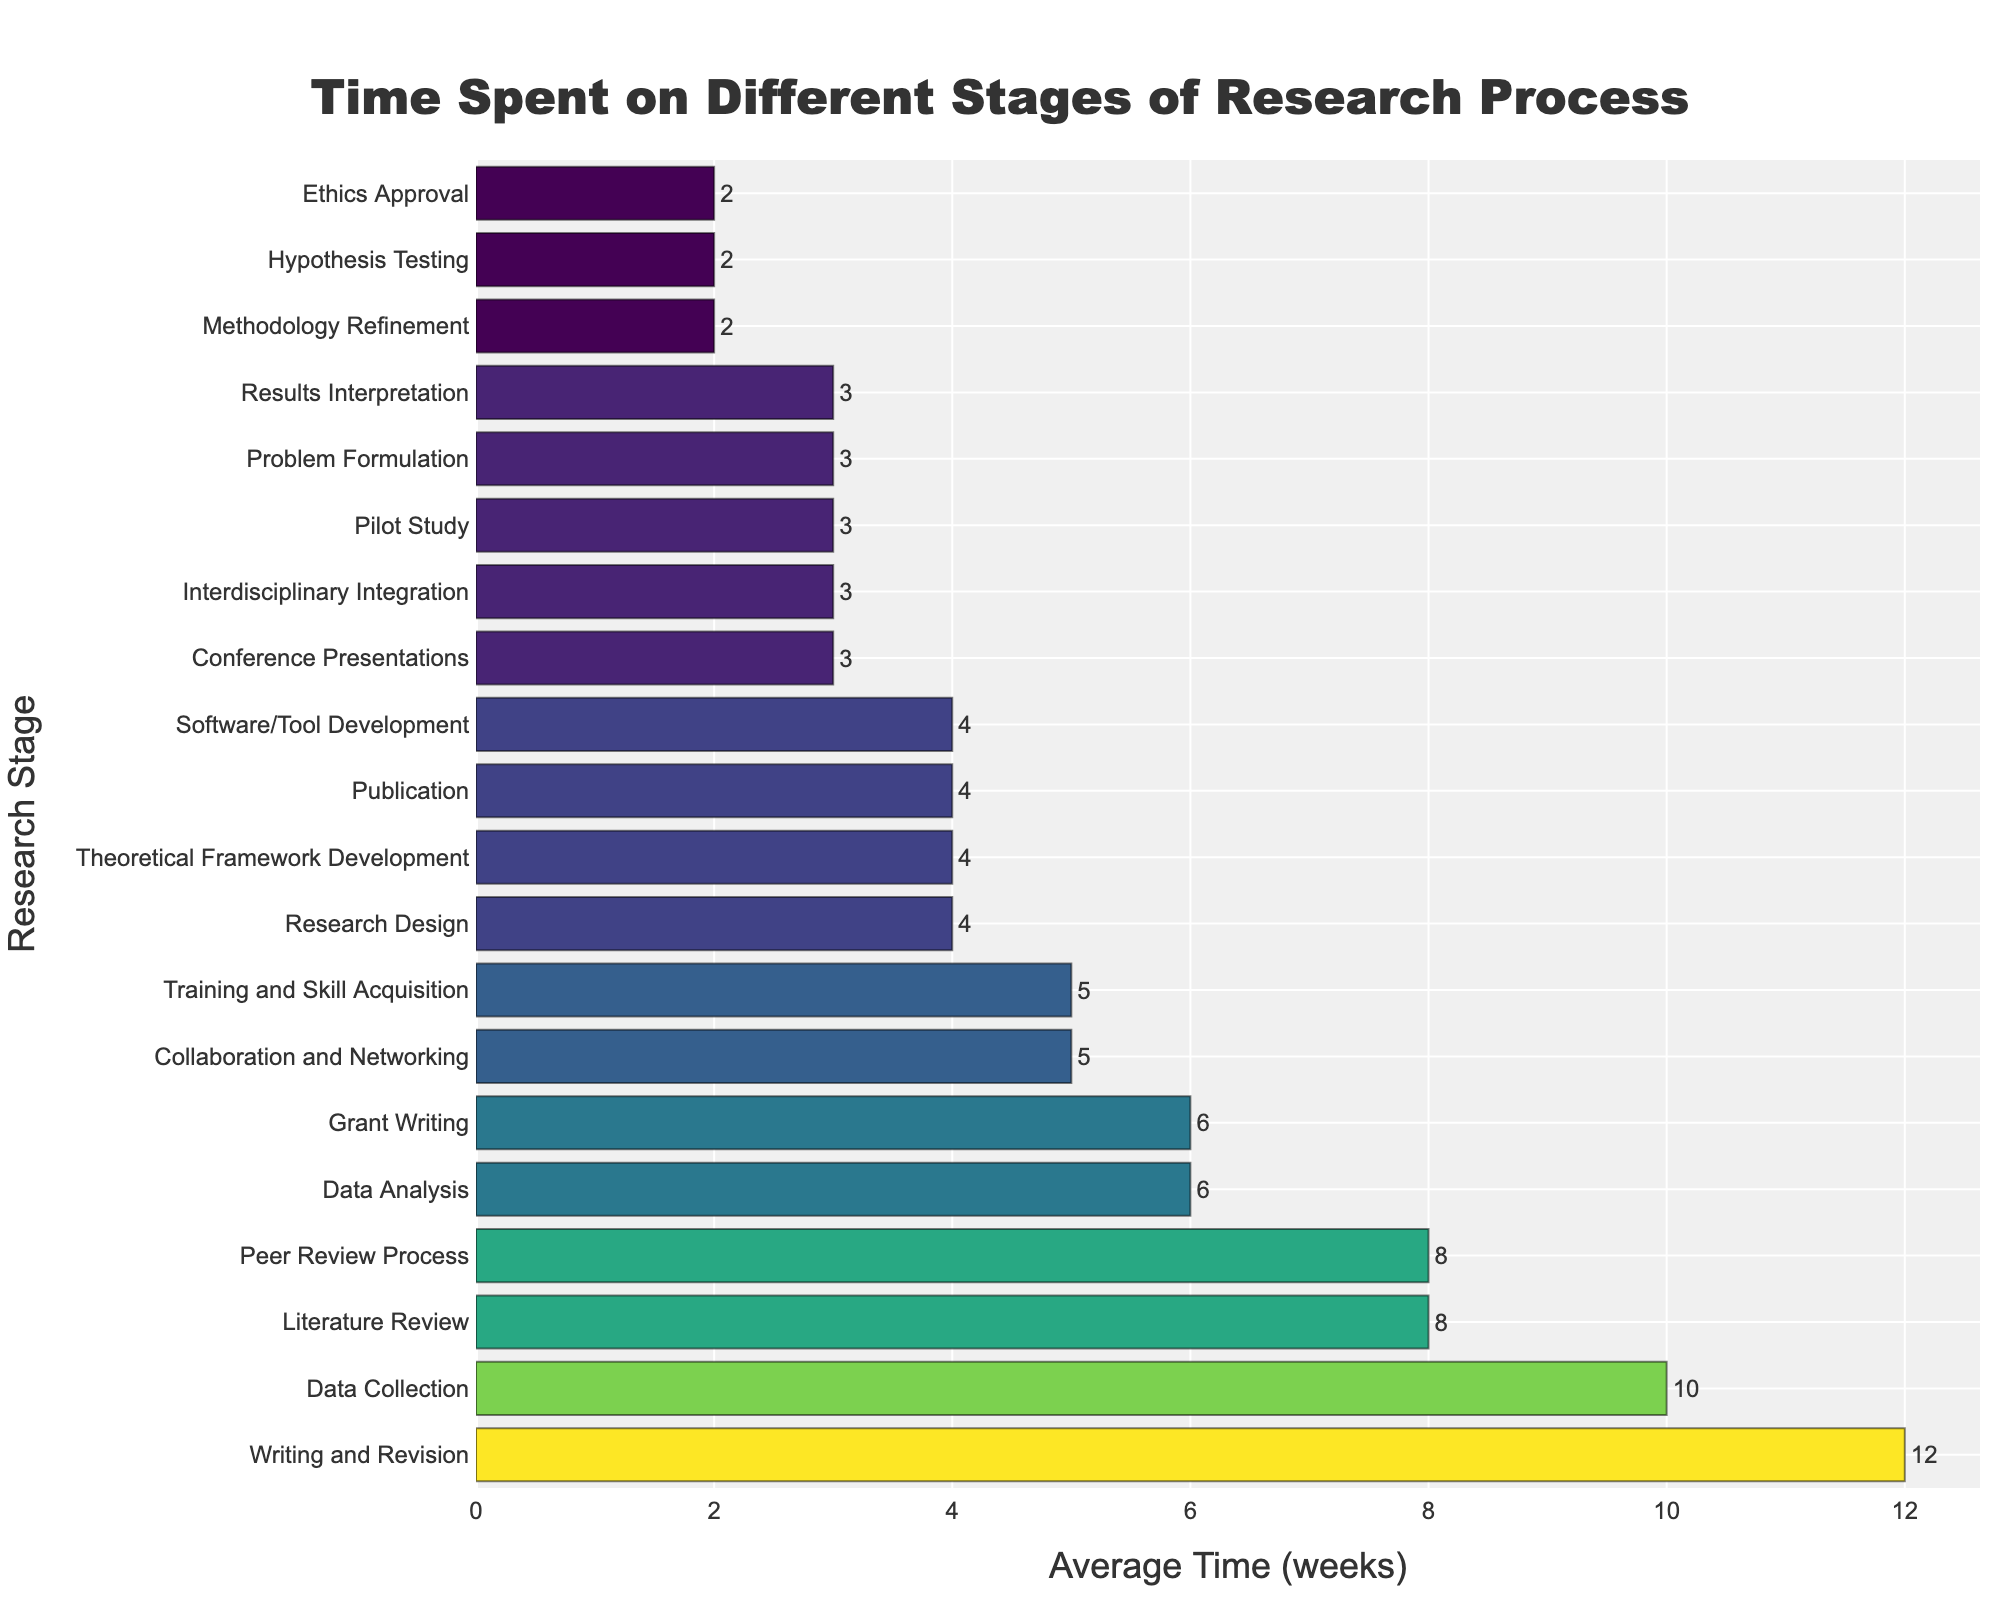Which stage has the highest average time spent? The bar chart shows the average time spent on different stages of the research process. By visually inspecting the length of the bars, the longest bar represents the stage with the highest average time spent.
Answer: Writing and Revision What is the combined average time spent on Data Collection, Data Analysis, and Data Collection? We need to sum up the average times of Data Collection (10 weeks), Data Analysis (6 weeks), and add Data Collection again (10 weeks). Therefore, the combined time is 10 + 6 + 10 = 26 weeks.
Answer: 26 weeks Which stage has a lower average time spent: Hypothesis Testing or Methodology Refinement? By comparing the lengths of the bars for Hypothesis Testing (2 weeks) and Methodology Refinement (2 weeks), we see that both stages have the same average time spent.
Answer: Equal How many stages have an average time spent of exactly 3 weeks? By identifying the bars that correspond to an average time of 3 weeks, we count the stages: Problem Formulation, Results Interpretation, Pilot Study, Conference Presentations, and Interdisciplinary Integration. That's 5 stages.
Answer: 5 stages What is the difference in average time spent between Literature Review and Ethics Approval? The average time spent on Literature Review is 8 weeks, and on Ethics Approval is 2 weeks. The difference is calculated as 8 - 2 = 6 weeks.
Answer: 6 weeks Which stage appears to be the most time-consuming after Writing and Revision? After identifying Writing and Revision as the most time-consuming, we look for the next longest bar, which represents Data Collection at 10 weeks.
Answer: Data Collection What is the average time spent on Collaboration and Networking compared to Grant Writing? The bar for Collaboration and Networking shows an average time of 5 weeks, while Grant Writing has 6 weeks. Collaboration and Networking takes 1 week less.
Answer: 1 week less If stages with more than 5 weeks are considered significant, how many stages fall into this category? By examining the bars, the stages with more than 5 weeks are: Literature Review, Data Collection, Writing and Revision, Peer Review Process, Grant Writing, and Training and Skill Acquisition. Thus, there are 6 stages.
Answer: 6 stages Which stages have exactly 4 weeks of average time spent? By observing the bars, we find the stages with 4 weeks of average time spent: Research Design, Publication, Software/Tool Development, and Theoretical Framework Development.
Answer: Research Design, Publication, Software/Tool Development, Theoretical Framework Development What proportion of the total stages take 5 weeks or more on average? First, we count the total number of stages, which is 20. Then, we identify the stages that have an average time of 5 weeks or more: Literature Review, Data Collection, Writing and Revision, Peer Review Process, Grant Writing, Training and Skill Acquisition, and Collaboration and Networking. That's 7 stages. The proportion is 7/20.
Answer: 7/20 